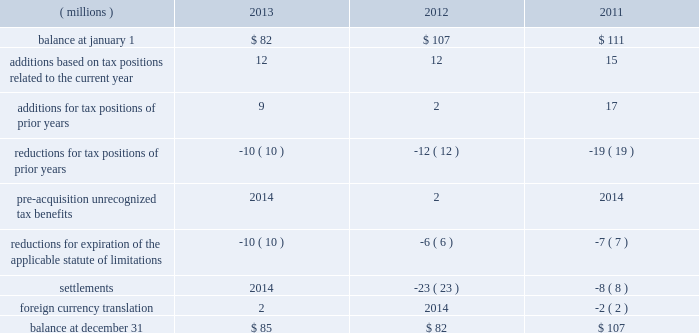52 2013 ppg annual report and form 10-k repatriation of undistributed earnings of non-u.s .
Subsidiaries as of december 31 , 2013 and december 31 , 2012 would have resulted in a u.s .
Tax cost of approximately $ 250 million and $ 110 million , respectively .
The company files federal , state and local income tax returns in numerous domestic and foreign jurisdictions .
In most tax jurisdictions , returns are subject to examination by the relevant tax authorities for a number of years after the returns have been filed .
The company is no longer subject to examinations by tax authorities in any major tax jurisdiction for years before 2006 .
Additionally , the internal revenue service has completed its examination of the company 2019s u.s .
Federal income tax returns filed for years through 2010 .
The examination of the company 2019s u.s .
Federal income tax return for 2011 is currently underway and is expected to be finalized during 2014 .
A reconciliation of the total amounts of unrecognized tax benefits ( excluding interest and penalties ) as of december 31 follows: .
The company expects that any reasonably possible change in the amount of unrecognized tax benefits in the next 12 months would not be significant .
The total amount of unrecognized tax benefits that , if recognized , would affect the effective tax rate was $ 81 million as of december 31 , 2013 .
The company recognizes accrued interest and penalties related to unrecognized tax benefits in income tax expense .
As of december 31 , 2013 , 2012 and 2011 , the company had liabilities for estimated interest and penalties on unrecognized tax benefits of $ 9 million , $ 10 million and $ 15 million , respectively .
The company recognized $ 2 million and $ 5 million of income in 2013 and 2012 , respectively , related to the reduction of estimated interest and penalties .
The company recognized no income or expense for estimated interest and penalties during the year ended december 31 , 2011 .
13 .
Pensions and other postretirement benefits defined benefit plans ppg has defined benefit pension plans that cover certain employees worldwide .
The principal defined benefit pension plans are those in the u.s. , canada , the netherlands and the u.k .
Which , in the aggregate represent approximately 91% ( 91 % ) of the projected benefit obligation at december 31 , 2013 , of which the u.s .
Defined benefit pension plans represent the majority .
Ppg also sponsors welfare benefit plans that provide postretirement medical and life insurance benefits for certain u.s .
And canadian employees and their dependents .
These programs require retiree contributions based on retiree-selected coverage levels for certain retirees and their dependents and provide for sharing of future benefit cost increases between ppg and participants based on management discretion .
The company has the right to modify or terminate certain of these benefit plans in the future .
Salaried and certain hourly employees in the u.s .
Hired on or after october 1 , 2004 , or rehired on or after october 1 , 2012 are not eligible for postretirement medical benefits .
Salaried employees in the u.s .
Hired , rehired or transferred to salaried status on or after january 1 , 2006 , and certain u.s .
Hourly employees hired in 2006 or thereafter are eligible to participate in a defined contribution retirement plan .
These employees are not eligible for defined benefit pension plan benefits .
Plan design changes in january 2011 , the company approved an amendment to one of its u.s .
Defined benefit pension plans that represented about 77% ( 77 % ) of the total u.s .
Projected benefit obligation at december 31 , 2011 .
Depending upon the affected employee's combined age and years of service to ppg , this change resulted in certain employees no longer accruing benefits under this plan as of december 31 , 2011 , while the remaining employees will no longer accrue benefits under this plan as of december 31 , 2020 .
The affected employees will participate in the company 2019s defined contribution retirement plan from the date their benefit under the defined benefit plan is frozen .
The company remeasured the projected benefit obligation of this amended plan , which lowered 2011 pension expense by approximately $ 12 million .
The company made similar changes to certain other u.s .
Defined benefit pension plans in 2011 .
The company recognized a curtailment loss and special termination benefits associated with these plan amendments of $ 5 million in 2011 .
The company plans to continue reviewing and potentially changing other ppg defined benefit plans in the future .
Separation and merger of commodity chemicals business on january 28 , 2013 , ppg completed the separation of its commodity chemicals business and the merger of the subsidiary holding the ppg commodity chemicals business with a subsidiary of georgia gulf , as discussed in note 22 , 201cseparation and merger transaction . 201d ppg transferred the defined benefit pension plan and other postretirement benefit liabilities for the affected employees in the u.s. , canada , and taiwan in the separation resulting in a net partial settlement loss of $ 33 million notes to the consolidated financial statements .
What was the percentage change in the unrecognized tax benefits from 2011 to 2012? 
Computations: ((82 - 107) / 107)
Answer: -0.23364. 52 2013 ppg annual report and form 10-k repatriation of undistributed earnings of non-u.s .
Subsidiaries as of december 31 , 2013 and december 31 , 2012 would have resulted in a u.s .
Tax cost of approximately $ 250 million and $ 110 million , respectively .
The company files federal , state and local income tax returns in numerous domestic and foreign jurisdictions .
In most tax jurisdictions , returns are subject to examination by the relevant tax authorities for a number of years after the returns have been filed .
The company is no longer subject to examinations by tax authorities in any major tax jurisdiction for years before 2006 .
Additionally , the internal revenue service has completed its examination of the company 2019s u.s .
Federal income tax returns filed for years through 2010 .
The examination of the company 2019s u.s .
Federal income tax return for 2011 is currently underway and is expected to be finalized during 2014 .
A reconciliation of the total amounts of unrecognized tax benefits ( excluding interest and penalties ) as of december 31 follows: .
The company expects that any reasonably possible change in the amount of unrecognized tax benefits in the next 12 months would not be significant .
The total amount of unrecognized tax benefits that , if recognized , would affect the effective tax rate was $ 81 million as of december 31 , 2013 .
The company recognizes accrued interest and penalties related to unrecognized tax benefits in income tax expense .
As of december 31 , 2013 , 2012 and 2011 , the company had liabilities for estimated interest and penalties on unrecognized tax benefits of $ 9 million , $ 10 million and $ 15 million , respectively .
The company recognized $ 2 million and $ 5 million of income in 2013 and 2012 , respectively , related to the reduction of estimated interest and penalties .
The company recognized no income or expense for estimated interest and penalties during the year ended december 31 , 2011 .
13 .
Pensions and other postretirement benefits defined benefit plans ppg has defined benefit pension plans that cover certain employees worldwide .
The principal defined benefit pension plans are those in the u.s. , canada , the netherlands and the u.k .
Which , in the aggregate represent approximately 91% ( 91 % ) of the projected benefit obligation at december 31 , 2013 , of which the u.s .
Defined benefit pension plans represent the majority .
Ppg also sponsors welfare benefit plans that provide postretirement medical and life insurance benefits for certain u.s .
And canadian employees and their dependents .
These programs require retiree contributions based on retiree-selected coverage levels for certain retirees and their dependents and provide for sharing of future benefit cost increases between ppg and participants based on management discretion .
The company has the right to modify or terminate certain of these benefit plans in the future .
Salaried and certain hourly employees in the u.s .
Hired on or after october 1 , 2004 , or rehired on or after october 1 , 2012 are not eligible for postretirement medical benefits .
Salaried employees in the u.s .
Hired , rehired or transferred to salaried status on or after january 1 , 2006 , and certain u.s .
Hourly employees hired in 2006 or thereafter are eligible to participate in a defined contribution retirement plan .
These employees are not eligible for defined benefit pension plan benefits .
Plan design changes in january 2011 , the company approved an amendment to one of its u.s .
Defined benefit pension plans that represented about 77% ( 77 % ) of the total u.s .
Projected benefit obligation at december 31 , 2011 .
Depending upon the affected employee's combined age and years of service to ppg , this change resulted in certain employees no longer accruing benefits under this plan as of december 31 , 2011 , while the remaining employees will no longer accrue benefits under this plan as of december 31 , 2020 .
The affected employees will participate in the company 2019s defined contribution retirement plan from the date their benefit under the defined benefit plan is frozen .
The company remeasured the projected benefit obligation of this amended plan , which lowered 2011 pension expense by approximately $ 12 million .
The company made similar changes to certain other u.s .
Defined benefit pension plans in 2011 .
The company recognized a curtailment loss and special termination benefits associated with these plan amendments of $ 5 million in 2011 .
The company plans to continue reviewing and potentially changing other ppg defined benefit plans in the future .
Separation and merger of commodity chemicals business on january 28 , 2013 , ppg completed the separation of its commodity chemicals business and the merger of the subsidiary holding the ppg commodity chemicals business with a subsidiary of georgia gulf , as discussed in note 22 , 201cseparation and merger transaction . 201d ppg transferred the defined benefit pension plan and other postretirement benefit liabilities for the affected employees in the u.s. , canada , and taiwan in the separation resulting in a net partial settlement loss of $ 33 million notes to the consolidated financial statements .
What was the percentage change in the unrecognized tax benefits from 2012 to 2013? 
Computations: ((85 - 82) / 82)
Answer: 0.03659. 